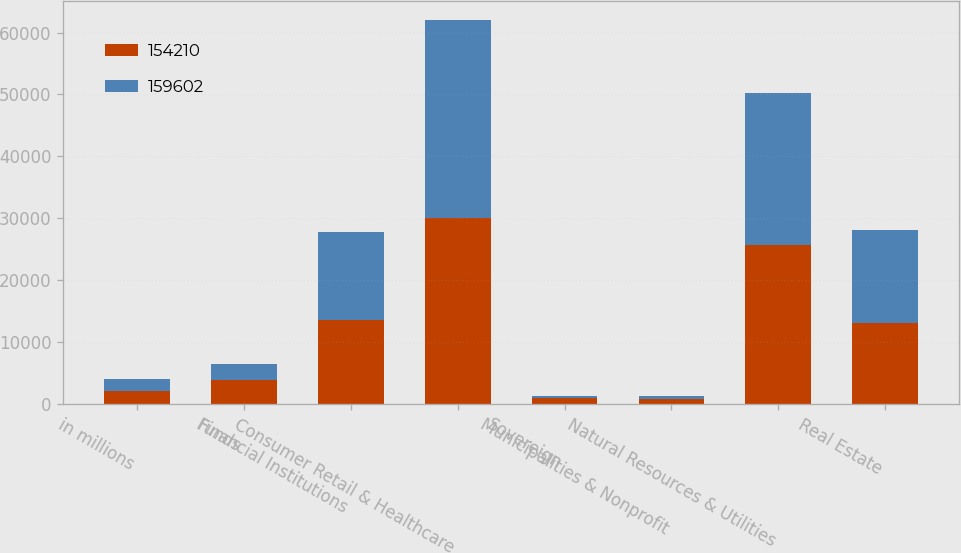Convert chart to OTSL. <chart><loc_0><loc_0><loc_500><loc_500><stacked_bar_chart><ecel><fcel>in millions<fcel>Funds<fcel>Financial Institutions<fcel>Consumer Retail & Healthcare<fcel>Sovereign<fcel>Municipalities & Nonprofit<fcel>Natural Resources & Utilities<fcel>Real Estate<nl><fcel>154210<fcel>2016<fcel>3854<fcel>13630<fcel>30007<fcel>902<fcel>709<fcel>25694<fcel>13034<nl><fcel>159602<fcel>2015<fcel>2595<fcel>14063<fcel>31944<fcel>419<fcel>628<fcel>24476<fcel>15045<nl></chart> 